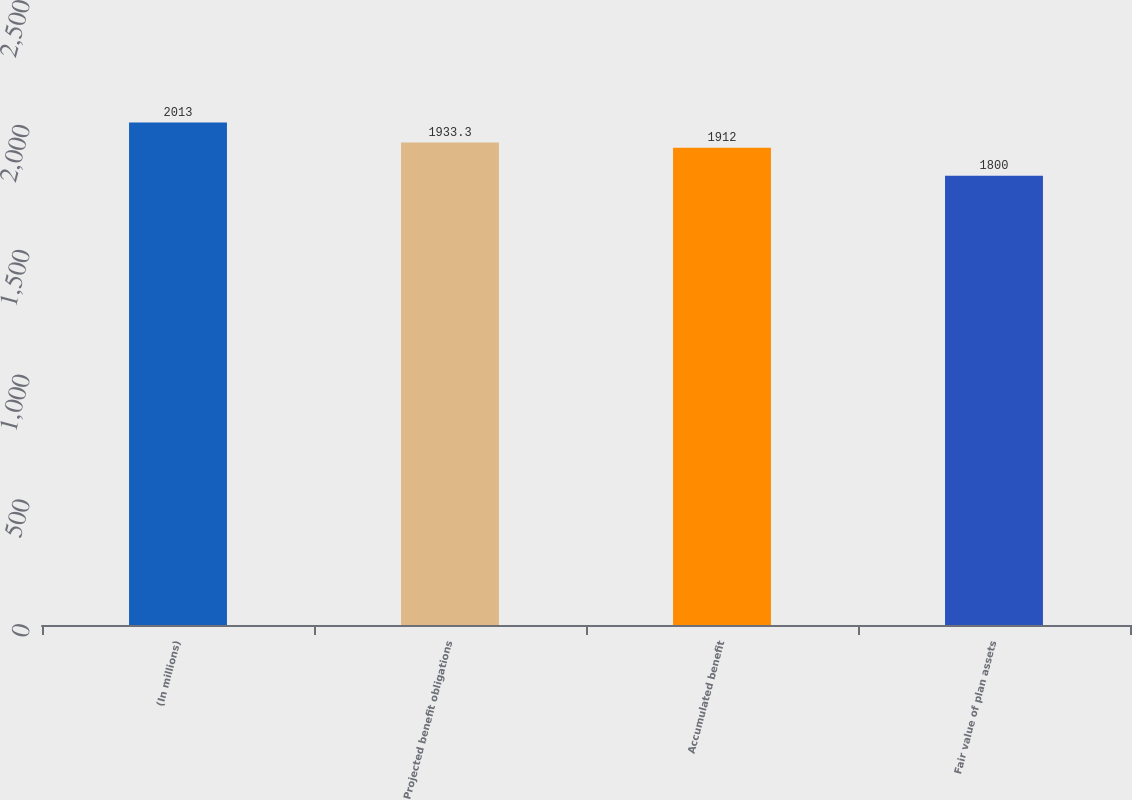<chart> <loc_0><loc_0><loc_500><loc_500><bar_chart><fcel>(In millions)<fcel>Projected benefit obligations<fcel>Accumulated benefit<fcel>Fair value of plan assets<nl><fcel>2013<fcel>1933.3<fcel>1912<fcel>1800<nl></chart> 